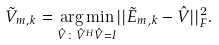Convert formula to latex. <formula><loc_0><loc_0><loc_500><loc_500>\tilde { V } _ { m , k } = \underset { \hat { V } \colon \hat { V } ^ { H } \hat { V } = I } { \arg \min } | | \tilde { E } _ { m , k } - \hat { V } | | _ { F } ^ { 2 } .</formula> 